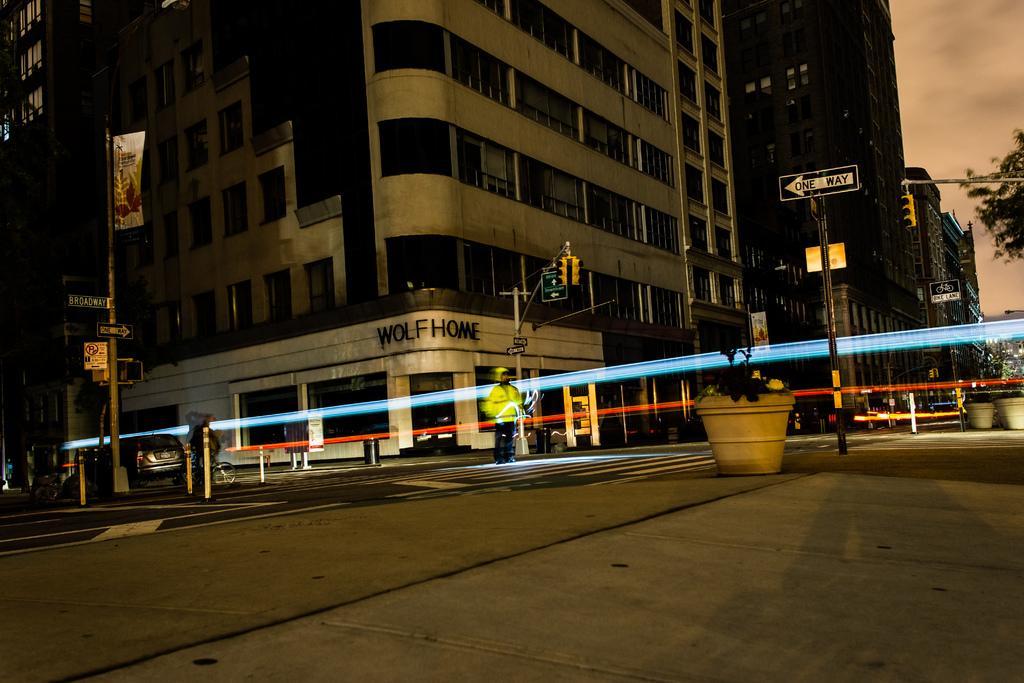How would you summarize this image in a sentence or two? It seems like an edited image. There is a road at the bottom. There are vehicles, people, a pole and there is a building on the left corner. There are trees and potted plants on the right corner. There are potted plants, there is a person, a pole in the foreground. There is a building with text in the background. And there are clouds in the sky. 